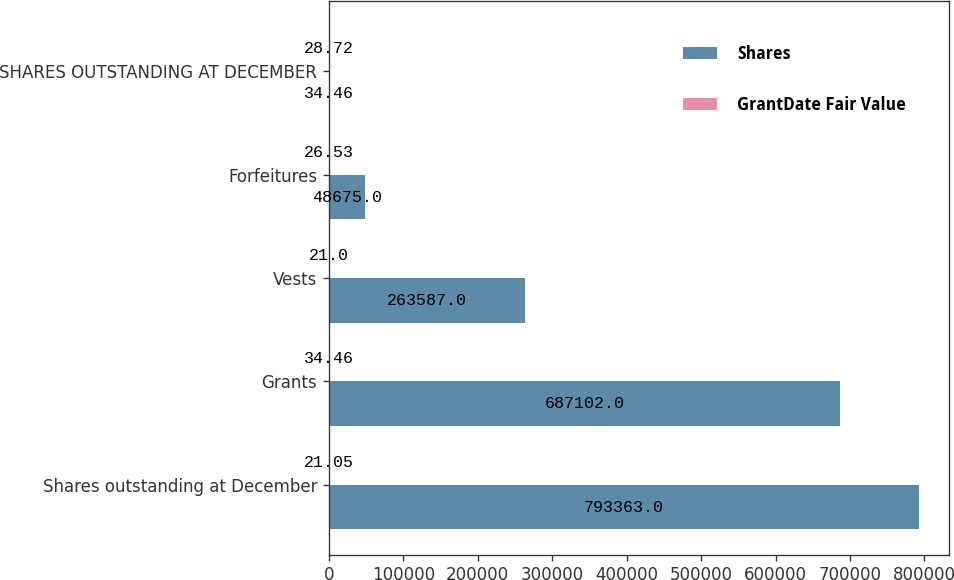<chart> <loc_0><loc_0><loc_500><loc_500><stacked_bar_chart><ecel><fcel>Shares outstanding at December<fcel>Grants<fcel>Vests<fcel>Forfeitures<fcel>SHARES OUTSTANDING AT DECEMBER<nl><fcel>Shares<fcel>793363<fcel>687102<fcel>263587<fcel>48675<fcel>34.46<nl><fcel>GrantDate Fair Value<fcel>21.05<fcel>34.46<fcel>21<fcel>26.53<fcel>28.72<nl></chart> 